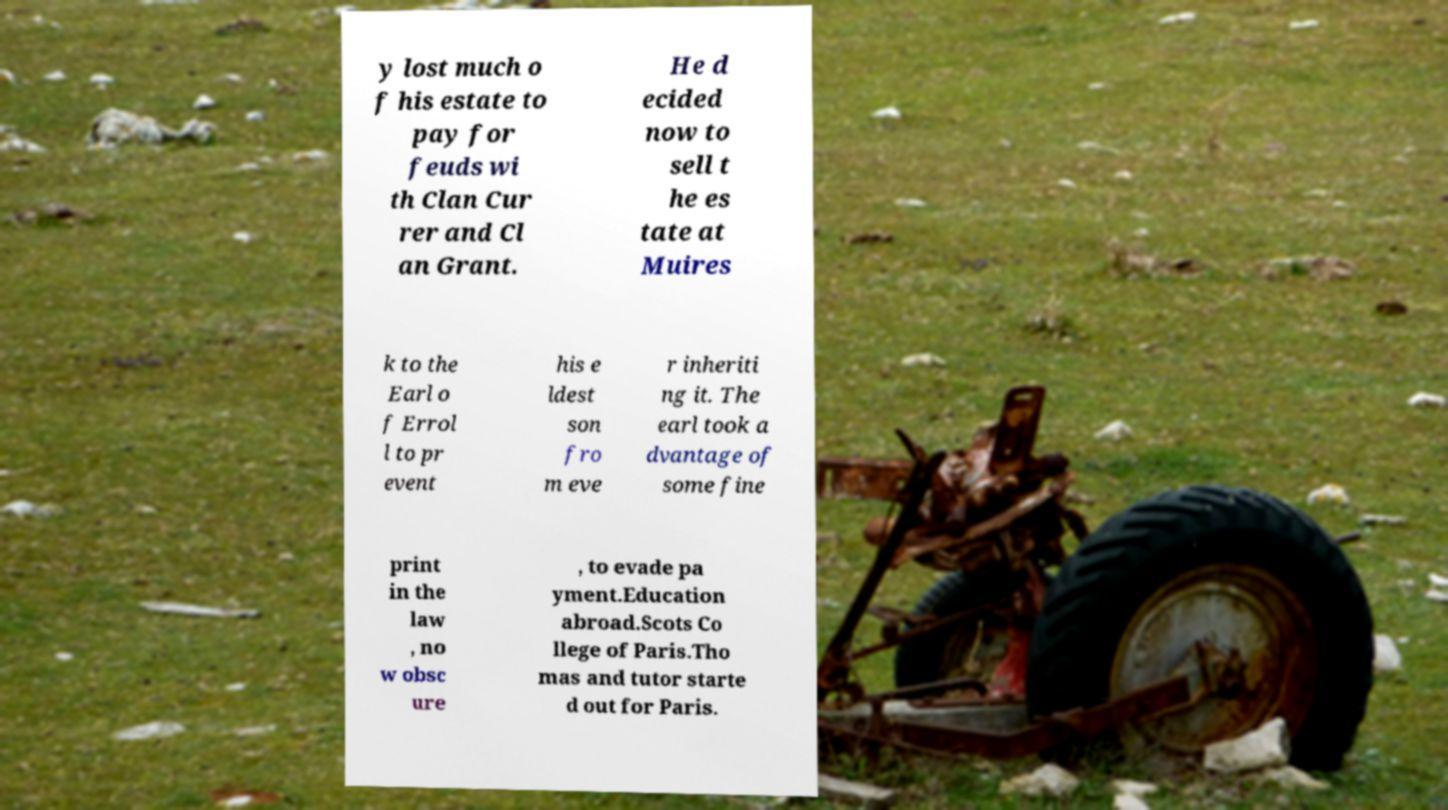Can you read and provide the text displayed in the image?This photo seems to have some interesting text. Can you extract and type it out for me? y lost much o f his estate to pay for feuds wi th Clan Cur rer and Cl an Grant. He d ecided now to sell t he es tate at Muires k to the Earl o f Errol l to pr event his e ldest son fro m eve r inheriti ng it. The earl took a dvantage of some fine print in the law , no w obsc ure , to evade pa yment.Education abroad.Scots Co llege of Paris.Tho mas and tutor starte d out for Paris. 